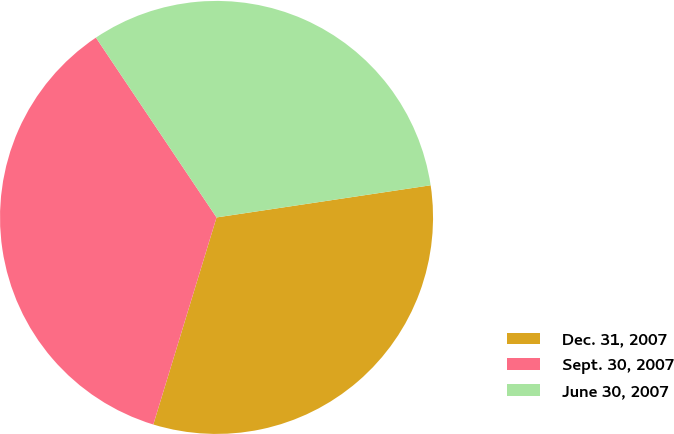<chart> <loc_0><loc_0><loc_500><loc_500><pie_chart><fcel>Dec. 31, 2007<fcel>Sept. 30, 2007<fcel>June 30, 2007<nl><fcel>32.09%<fcel>35.88%<fcel>32.03%<nl></chart> 